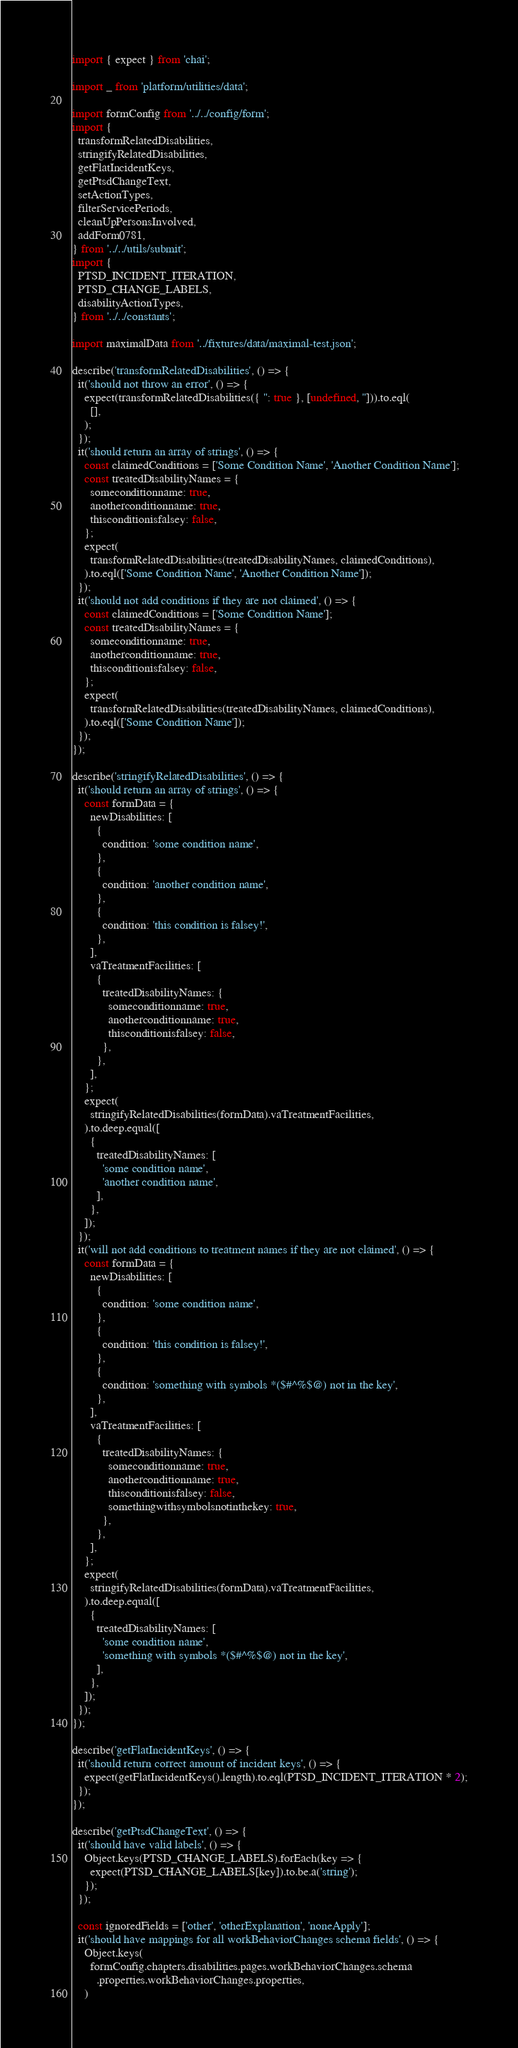Convert code to text. <code><loc_0><loc_0><loc_500><loc_500><_JavaScript_>import { expect } from 'chai';

import _ from 'platform/utilities/data';

import formConfig from '../../config/form';
import {
  transformRelatedDisabilities,
  stringifyRelatedDisabilities,
  getFlatIncidentKeys,
  getPtsdChangeText,
  setActionTypes,
  filterServicePeriods,
  cleanUpPersonsInvolved,
  addForm0781,
} from '../../utils/submit';
import {
  PTSD_INCIDENT_ITERATION,
  PTSD_CHANGE_LABELS,
  disabilityActionTypes,
} from '../../constants';

import maximalData from '../fixtures/data/maximal-test.json';

describe('transformRelatedDisabilities', () => {
  it('should not throw an error', () => {
    expect(transformRelatedDisabilities({ '': true }, [undefined, ''])).to.eql(
      [],
    );
  });
  it('should return an array of strings', () => {
    const claimedConditions = ['Some Condition Name', 'Another Condition Name'];
    const treatedDisabilityNames = {
      someconditionname: true,
      anotherconditionname: true,
      thisconditionisfalsey: false,
    };
    expect(
      transformRelatedDisabilities(treatedDisabilityNames, claimedConditions),
    ).to.eql(['Some Condition Name', 'Another Condition Name']);
  });
  it('should not add conditions if they are not claimed', () => {
    const claimedConditions = ['Some Condition Name'];
    const treatedDisabilityNames = {
      someconditionname: true,
      anotherconditionname: true,
      thisconditionisfalsey: false,
    };
    expect(
      transformRelatedDisabilities(treatedDisabilityNames, claimedConditions),
    ).to.eql(['Some Condition Name']);
  });
});

describe('stringifyRelatedDisabilities', () => {
  it('should return an array of strings', () => {
    const formData = {
      newDisabilities: [
        {
          condition: 'some condition name',
        },
        {
          condition: 'another condition name',
        },
        {
          condition: 'this condition is falsey!',
        },
      ],
      vaTreatmentFacilities: [
        {
          treatedDisabilityNames: {
            someconditionname: true,
            anotherconditionname: true,
            thisconditionisfalsey: false,
          },
        },
      ],
    };
    expect(
      stringifyRelatedDisabilities(formData).vaTreatmentFacilities,
    ).to.deep.equal([
      {
        treatedDisabilityNames: [
          'some condition name',
          'another condition name',
        ],
      },
    ]);
  });
  it('will not add conditions to treatment names if they are not claimed', () => {
    const formData = {
      newDisabilities: [
        {
          condition: 'some condition name',
        },
        {
          condition: 'this condition is falsey!',
        },
        {
          condition: 'something with symbols *($#^%$@) not in the key',
        },
      ],
      vaTreatmentFacilities: [
        {
          treatedDisabilityNames: {
            someconditionname: true,
            anotherconditionname: true,
            thisconditionisfalsey: false,
            somethingwithsymbolsnotinthekey: true,
          },
        },
      ],
    };
    expect(
      stringifyRelatedDisabilities(formData).vaTreatmentFacilities,
    ).to.deep.equal([
      {
        treatedDisabilityNames: [
          'some condition name',
          'something with symbols *($#^%$@) not in the key',
        ],
      },
    ]);
  });
});

describe('getFlatIncidentKeys', () => {
  it('should return correct amount of incident keys', () => {
    expect(getFlatIncidentKeys().length).to.eql(PTSD_INCIDENT_ITERATION * 2);
  });
});

describe('getPtsdChangeText', () => {
  it('should have valid labels', () => {
    Object.keys(PTSD_CHANGE_LABELS).forEach(key => {
      expect(PTSD_CHANGE_LABELS[key]).to.be.a('string');
    });
  });

  const ignoredFields = ['other', 'otherExplanation', 'noneApply'];
  it('should have mappings for all workBehaviorChanges schema fields', () => {
    Object.keys(
      formConfig.chapters.disabilities.pages.workBehaviorChanges.schema
        .properties.workBehaviorChanges.properties,
    )</code> 